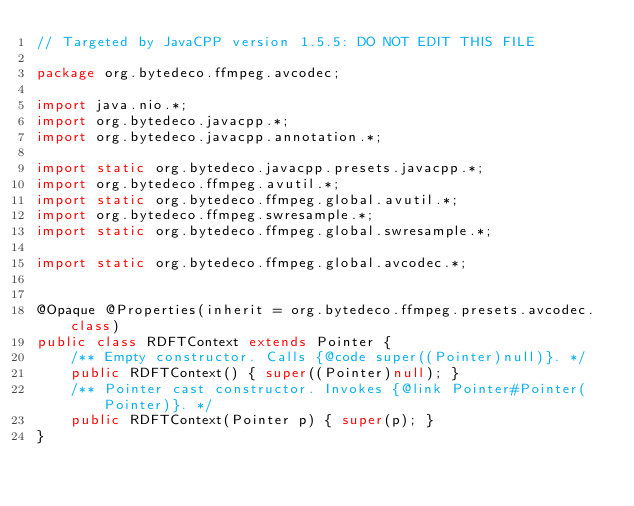Convert code to text. <code><loc_0><loc_0><loc_500><loc_500><_Java_>// Targeted by JavaCPP version 1.5.5: DO NOT EDIT THIS FILE

package org.bytedeco.ffmpeg.avcodec;

import java.nio.*;
import org.bytedeco.javacpp.*;
import org.bytedeco.javacpp.annotation.*;

import static org.bytedeco.javacpp.presets.javacpp.*;
import org.bytedeco.ffmpeg.avutil.*;
import static org.bytedeco.ffmpeg.global.avutil.*;
import org.bytedeco.ffmpeg.swresample.*;
import static org.bytedeco.ffmpeg.global.swresample.*;

import static org.bytedeco.ffmpeg.global.avcodec.*;


@Opaque @Properties(inherit = org.bytedeco.ffmpeg.presets.avcodec.class)
public class RDFTContext extends Pointer {
    /** Empty constructor. Calls {@code super((Pointer)null)}. */
    public RDFTContext() { super((Pointer)null); }
    /** Pointer cast constructor. Invokes {@link Pointer#Pointer(Pointer)}. */
    public RDFTContext(Pointer p) { super(p); }
}
</code> 